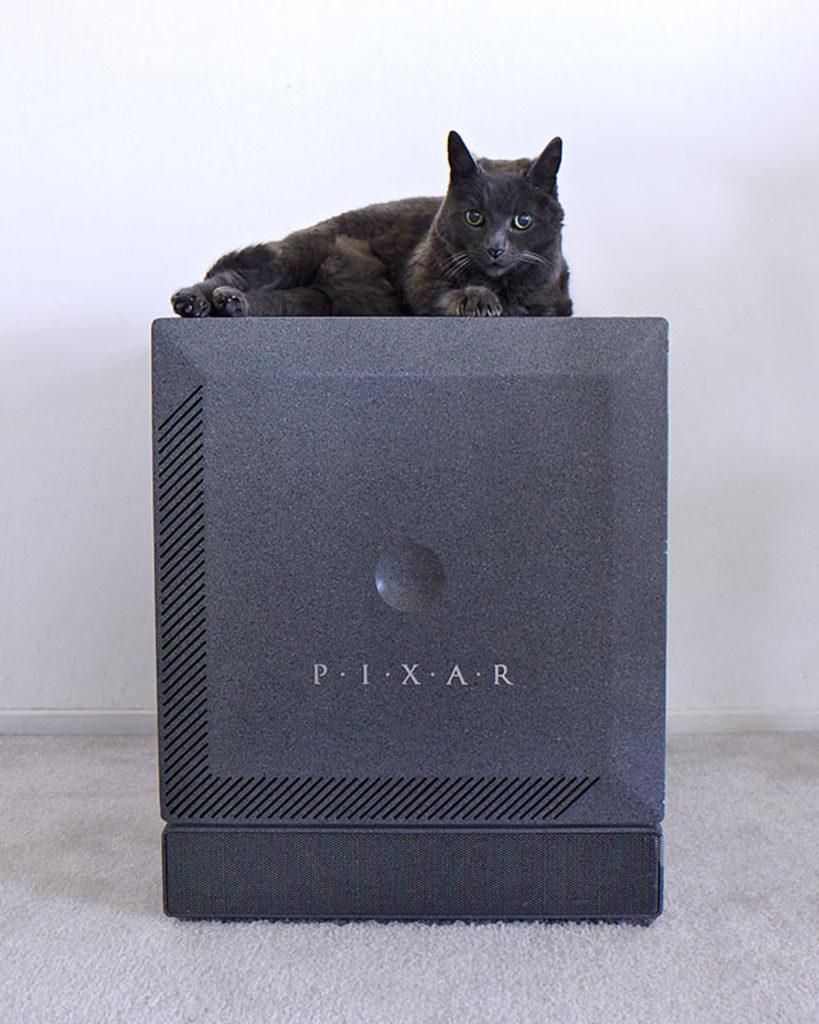What type of animal is in the image? There is a black cat in the image. What is the cat doing in the image? The cat is lying on an object. Where is the object located in the image? The object is on the floor. What can be seen in the background of the image? There is a wall in the background of the image. What type of creature is waving its side in the image? There is no creature waving its side in the image; it only features a black cat lying on an object. 